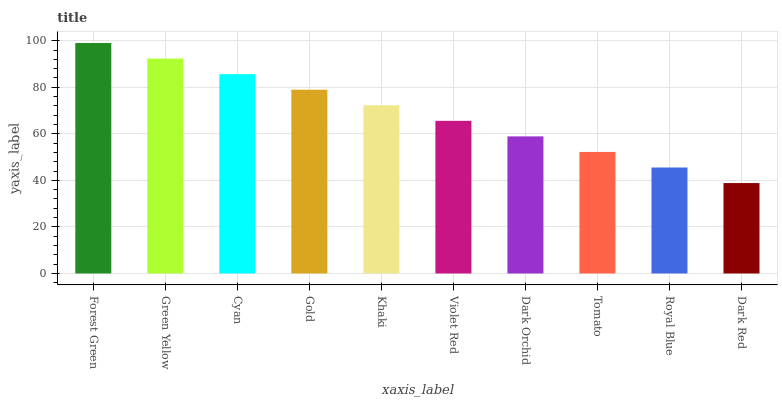Is Green Yellow the minimum?
Answer yes or no. No. Is Green Yellow the maximum?
Answer yes or no. No. Is Forest Green greater than Green Yellow?
Answer yes or no. Yes. Is Green Yellow less than Forest Green?
Answer yes or no. Yes. Is Green Yellow greater than Forest Green?
Answer yes or no. No. Is Forest Green less than Green Yellow?
Answer yes or no. No. Is Khaki the high median?
Answer yes or no. Yes. Is Violet Red the low median?
Answer yes or no. Yes. Is Cyan the high median?
Answer yes or no. No. Is Royal Blue the low median?
Answer yes or no. No. 